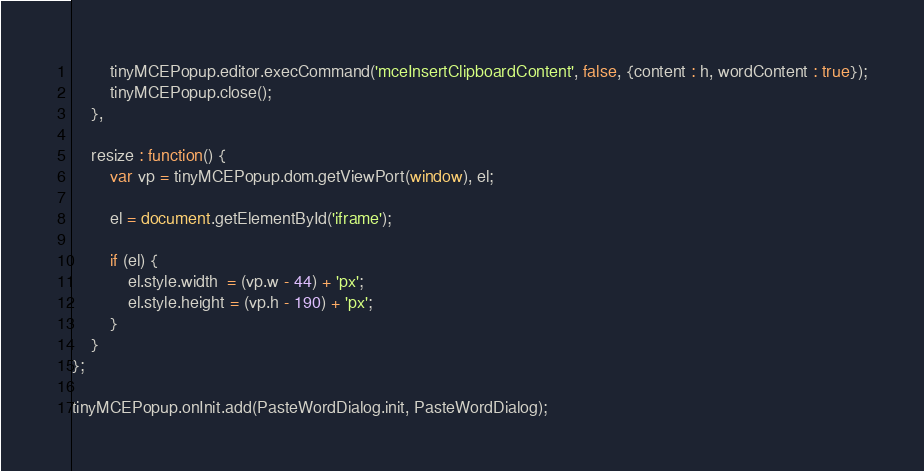<code> <loc_0><loc_0><loc_500><loc_500><_JavaScript_>		tinyMCEPopup.editor.execCommand('mceInsertClipboardContent', false, {content : h, wordContent : true});
		tinyMCEPopup.close();
	},

	resize : function() {
		var vp = tinyMCEPopup.dom.getViewPort(window), el;

		el = document.getElementById('iframe');

		if (el) {
			el.style.width  = (vp.w - 44) + 'px';
			el.style.height = (vp.h - 190) + 'px';
		}
	}
};

tinyMCEPopup.onInit.add(PasteWordDialog.init, PasteWordDialog);
</code> 